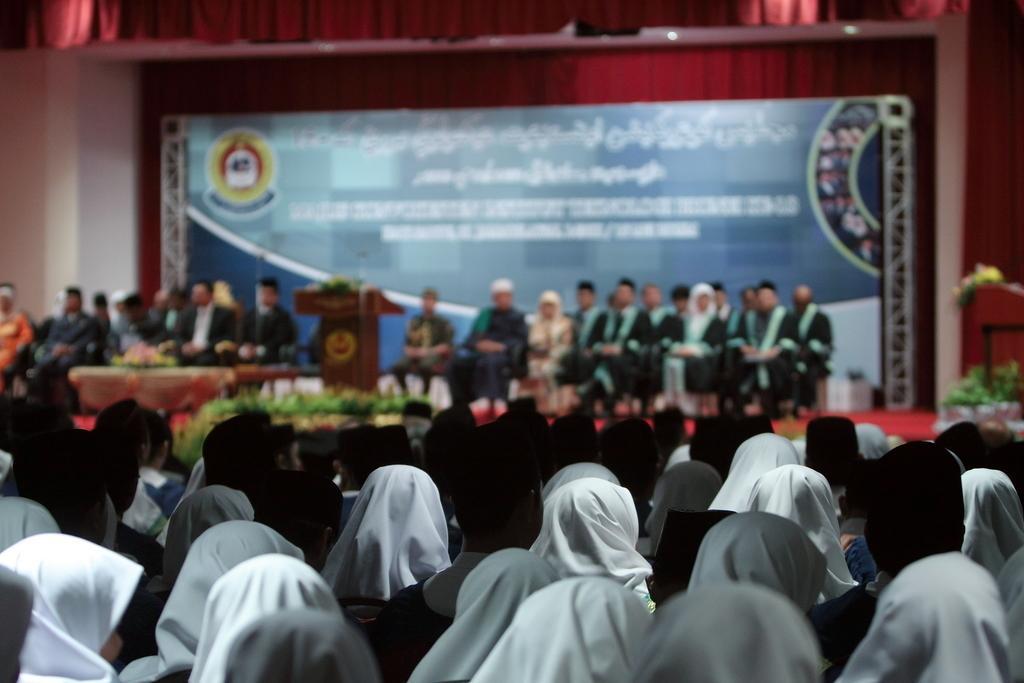Describe this image in one or two sentences. In this image there are persons sitting and there is a podium and on the top of the podium there is a mic. In the background there is a board with some text written on it and there are curtains which are red in colour. On the right side there are plants and flowers. In the center there are small plants which are visible. 